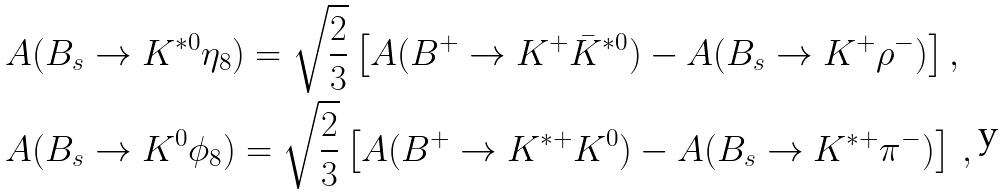Convert formula to latex. <formula><loc_0><loc_0><loc_500><loc_500>& A ( B _ { s } \to K ^ { * 0 } \eta _ { 8 } ) = \sqrt { \frac { 2 } { 3 } } \left [ A ( B ^ { + } \to K ^ { + } \bar { K } ^ { * 0 } ) - A ( B _ { s } \to K ^ { + } \rho ^ { - } ) \right ] , \\ & A ( B _ { s } \to K ^ { 0 } \phi _ { 8 } ) = \sqrt { \frac { 2 } { 3 } } \left [ A ( B ^ { + } \to K ^ { * + } K ^ { 0 } ) - A ( B _ { s } \to K ^ { * + } \pi ^ { - } ) \right ] \, ,</formula> 